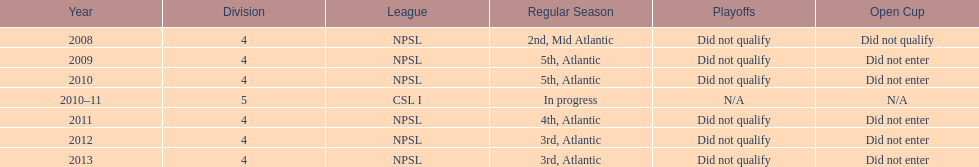What is the only year that is n/a? 2010-11. 